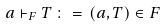<formula> <loc_0><loc_0><loc_500><loc_500>a \vdash _ { F } T \, \colon = \, ( a , T ) \in F</formula> 